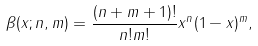Convert formula to latex. <formula><loc_0><loc_0><loc_500><loc_500>\beta ( x ; n , m ) = \frac { ( n + m + 1 ) ! } { n ! m ! } x ^ { n } ( 1 - x ) ^ { m } ,</formula> 